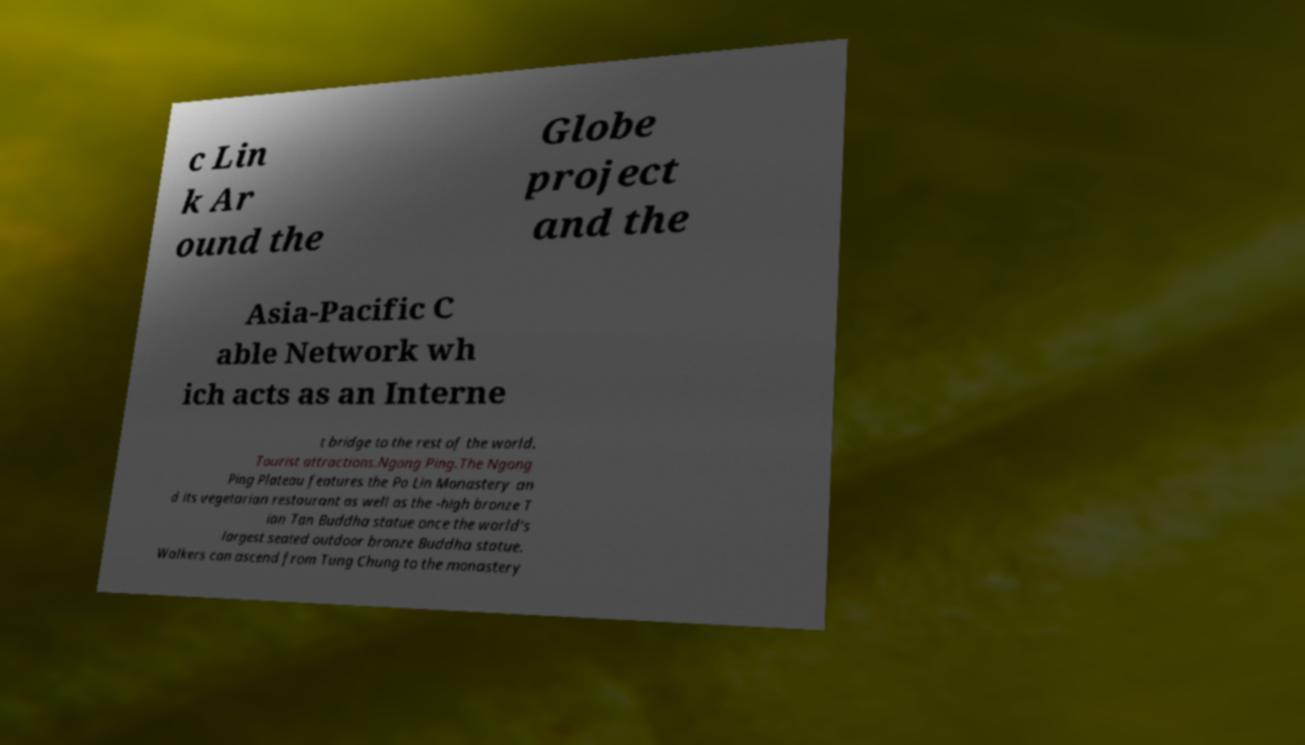Could you extract and type out the text from this image? c Lin k Ar ound the Globe project and the Asia-Pacific C able Network wh ich acts as an Interne t bridge to the rest of the world. Tourist attractions.Ngong Ping.The Ngong Ping Plateau features the Po Lin Monastery an d its vegetarian restaurant as well as the -high bronze T ian Tan Buddha statue once the world's largest seated outdoor bronze Buddha statue. Walkers can ascend from Tung Chung to the monastery 